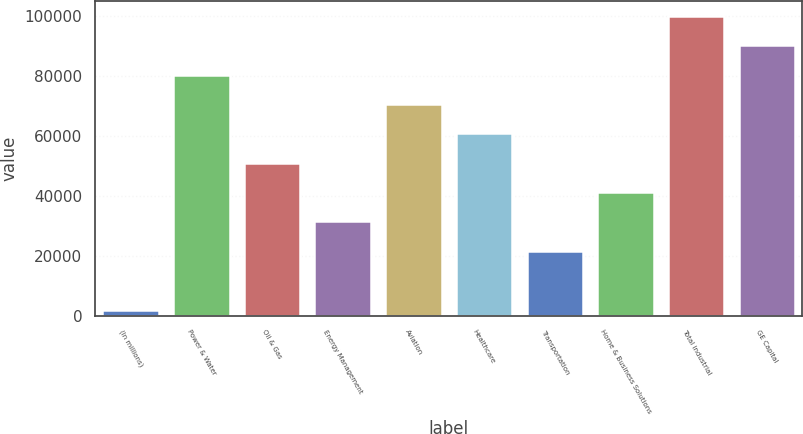Convert chart. <chart><loc_0><loc_0><loc_500><loc_500><bar_chart><fcel>(In millions)<fcel>Power & Water<fcel>Oil & Gas<fcel>Energy Management<fcel>Aviation<fcel>Healthcare<fcel>Transportation<fcel>Home & Business Solutions<fcel>Total industrial<fcel>GE Capital<nl><fcel>2012<fcel>80520.8<fcel>51080<fcel>31452.8<fcel>70707.2<fcel>60893.6<fcel>21639.2<fcel>41266.4<fcel>100148<fcel>90334.4<nl></chart> 